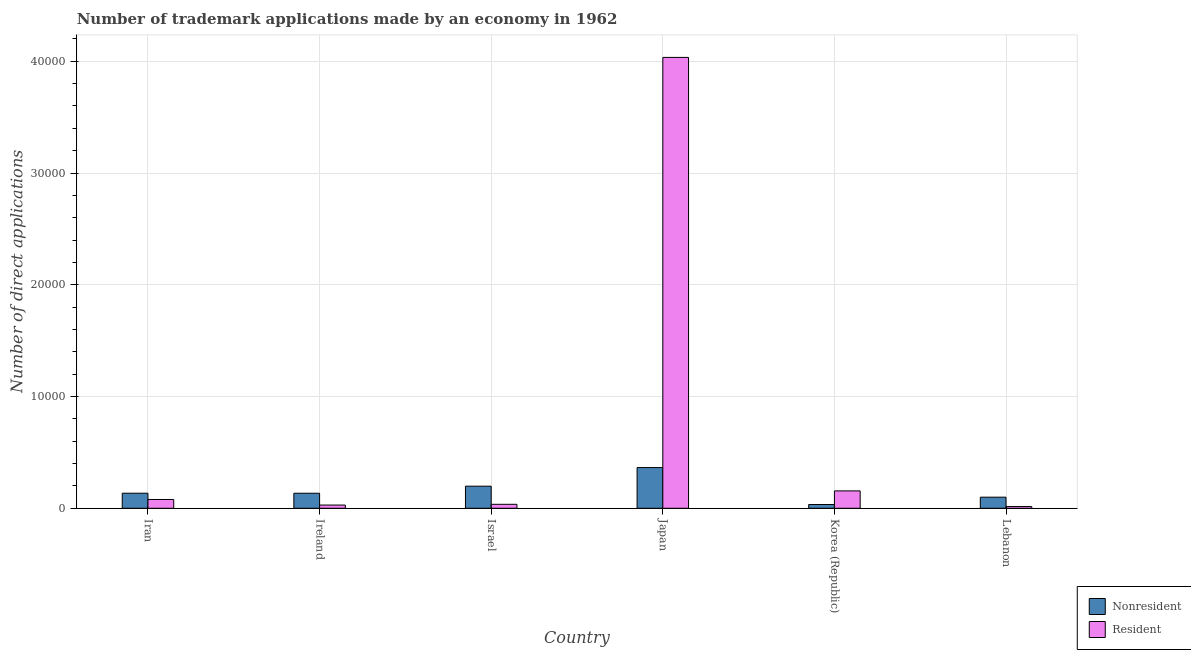How many different coloured bars are there?
Offer a terse response. 2. How many groups of bars are there?
Provide a short and direct response. 6. Are the number of bars per tick equal to the number of legend labels?
Your response must be concise. Yes. How many bars are there on the 3rd tick from the left?
Make the answer very short. 2. How many bars are there on the 5th tick from the right?
Offer a very short reply. 2. What is the label of the 2nd group of bars from the left?
Give a very brief answer. Ireland. What is the number of trademark applications made by residents in Lebanon?
Provide a short and direct response. 153. Across all countries, what is the maximum number of trademark applications made by non residents?
Offer a terse response. 3642. Across all countries, what is the minimum number of trademark applications made by non residents?
Offer a very short reply. 336. In which country was the number of trademark applications made by residents minimum?
Keep it short and to the point. Lebanon. What is the total number of trademark applications made by residents in the graph?
Ensure brevity in your answer.  4.35e+04. What is the difference between the number of trademark applications made by non residents in Korea (Republic) and that in Lebanon?
Offer a terse response. -656. What is the difference between the number of trademark applications made by residents in Iran and the number of trademark applications made by non residents in Japan?
Provide a short and direct response. -2856. What is the average number of trademark applications made by residents per country?
Provide a succinct answer. 7246.5. What is the difference between the number of trademark applications made by residents and number of trademark applications made by non residents in Korea (Republic)?
Your answer should be very brief. 1218. What is the ratio of the number of trademark applications made by non residents in Korea (Republic) to that in Lebanon?
Offer a very short reply. 0.34. Is the number of trademark applications made by residents in Israel less than that in Japan?
Provide a short and direct response. Yes. What is the difference between the highest and the second highest number of trademark applications made by non residents?
Your response must be concise. 1665. What is the difference between the highest and the lowest number of trademark applications made by residents?
Your response must be concise. 4.02e+04. Is the sum of the number of trademark applications made by residents in Ireland and Israel greater than the maximum number of trademark applications made by non residents across all countries?
Keep it short and to the point. No. What does the 2nd bar from the left in Iran represents?
Ensure brevity in your answer.  Resident. What does the 2nd bar from the right in Ireland represents?
Give a very brief answer. Nonresident. How many bars are there?
Offer a very short reply. 12. What is the difference between two consecutive major ticks on the Y-axis?
Provide a short and direct response. 10000. Where does the legend appear in the graph?
Ensure brevity in your answer.  Bottom right. How are the legend labels stacked?
Your response must be concise. Vertical. What is the title of the graph?
Give a very brief answer. Number of trademark applications made by an economy in 1962. Does "Frequency of shipment arrival" appear as one of the legend labels in the graph?
Your answer should be very brief. No. What is the label or title of the X-axis?
Provide a short and direct response. Country. What is the label or title of the Y-axis?
Provide a succinct answer. Number of direct applications. What is the Number of direct applications in Nonresident in Iran?
Give a very brief answer. 1348. What is the Number of direct applications in Resident in Iran?
Give a very brief answer. 786. What is the Number of direct applications in Nonresident in Ireland?
Your answer should be compact. 1345. What is the Number of direct applications in Resident in Ireland?
Make the answer very short. 288. What is the Number of direct applications in Nonresident in Israel?
Your answer should be compact. 1977. What is the Number of direct applications in Resident in Israel?
Ensure brevity in your answer.  355. What is the Number of direct applications of Nonresident in Japan?
Provide a succinct answer. 3642. What is the Number of direct applications of Resident in Japan?
Your answer should be very brief. 4.03e+04. What is the Number of direct applications in Nonresident in Korea (Republic)?
Provide a short and direct response. 336. What is the Number of direct applications in Resident in Korea (Republic)?
Offer a terse response. 1554. What is the Number of direct applications of Nonresident in Lebanon?
Ensure brevity in your answer.  992. What is the Number of direct applications of Resident in Lebanon?
Ensure brevity in your answer.  153. Across all countries, what is the maximum Number of direct applications of Nonresident?
Provide a short and direct response. 3642. Across all countries, what is the maximum Number of direct applications in Resident?
Keep it short and to the point. 4.03e+04. Across all countries, what is the minimum Number of direct applications of Nonresident?
Offer a terse response. 336. Across all countries, what is the minimum Number of direct applications of Resident?
Keep it short and to the point. 153. What is the total Number of direct applications in Nonresident in the graph?
Keep it short and to the point. 9640. What is the total Number of direct applications in Resident in the graph?
Provide a succinct answer. 4.35e+04. What is the difference between the Number of direct applications in Nonresident in Iran and that in Ireland?
Your response must be concise. 3. What is the difference between the Number of direct applications in Resident in Iran and that in Ireland?
Make the answer very short. 498. What is the difference between the Number of direct applications of Nonresident in Iran and that in Israel?
Offer a terse response. -629. What is the difference between the Number of direct applications of Resident in Iran and that in Israel?
Your answer should be very brief. 431. What is the difference between the Number of direct applications of Nonresident in Iran and that in Japan?
Provide a short and direct response. -2294. What is the difference between the Number of direct applications in Resident in Iran and that in Japan?
Offer a very short reply. -3.96e+04. What is the difference between the Number of direct applications in Nonresident in Iran and that in Korea (Republic)?
Give a very brief answer. 1012. What is the difference between the Number of direct applications of Resident in Iran and that in Korea (Republic)?
Keep it short and to the point. -768. What is the difference between the Number of direct applications in Nonresident in Iran and that in Lebanon?
Give a very brief answer. 356. What is the difference between the Number of direct applications in Resident in Iran and that in Lebanon?
Keep it short and to the point. 633. What is the difference between the Number of direct applications in Nonresident in Ireland and that in Israel?
Your response must be concise. -632. What is the difference between the Number of direct applications of Resident in Ireland and that in Israel?
Your answer should be compact. -67. What is the difference between the Number of direct applications of Nonresident in Ireland and that in Japan?
Your answer should be very brief. -2297. What is the difference between the Number of direct applications in Resident in Ireland and that in Japan?
Offer a terse response. -4.01e+04. What is the difference between the Number of direct applications in Nonresident in Ireland and that in Korea (Republic)?
Make the answer very short. 1009. What is the difference between the Number of direct applications in Resident in Ireland and that in Korea (Republic)?
Keep it short and to the point. -1266. What is the difference between the Number of direct applications in Nonresident in Ireland and that in Lebanon?
Ensure brevity in your answer.  353. What is the difference between the Number of direct applications of Resident in Ireland and that in Lebanon?
Keep it short and to the point. 135. What is the difference between the Number of direct applications of Nonresident in Israel and that in Japan?
Your answer should be compact. -1665. What is the difference between the Number of direct applications in Resident in Israel and that in Japan?
Your response must be concise. -4.00e+04. What is the difference between the Number of direct applications of Nonresident in Israel and that in Korea (Republic)?
Offer a very short reply. 1641. What is the difference between the Number of direct applications in Resident in Israel and that in Korea (Republic)?
Your answer should be compact. -1199. What is the difference between the Number of direct applications in Nonresident in Israel and that in Lebanon?
Your response must be concise. 985. What is the difference between the Number of direct applications of Resident in Israel and that in Lebanon?
Offer a very short reply. 202. What is the difference between the Number of direct applications of Nonresident in Japan and that in Korea (Republic)?
Provide a short and direct response. 3306. What is the difference between the Number of direct applications in Resident in Japan and that in Korea (Republic)?
Provide a short and direct response. 3.88e+04. What is the difference between the Number of direct applications of Nonresident in Japan and that in Lebanon?
Offer a terse response. 2650. What is the difference between the Number of direct applications of Resident in Japan and that in Lebanon?
Your response must be concise. 4.02e+04. What is the difference between the Number of direct applications in Nonresident in Korea (Republic) and that in Lebanon?
Provide a succinct answer. -656. What is the difference between the Number of direct applications in Resident in Korea (Republic) and that in Lebanon?
Make the answer very short. 1401. What is the difference between the Number of direct applications of Nonresident in Iran and the Number of direct applications of Resident in Ireland?
Provide a succinct answer. 1060. What is the difference between the Number of direct applications of Nonresident in Iran and the Number of direct applications of Resident in Israel?
Provide a succinct answer. 993. What is the difference between the Number of direct applications of Nonresident in Iran and the Number of direct applications of Resident in Japan?
Your answer should be very brief. -3.90e+04. What is the difference between the Number of direct applications of Nonresident in Iran and the Number of direct applications of Resident in Korea (Republic)?
Keep it short and to the point. -206. What is the difference between the Number of direct applications of Nonresident in Iran and the Number of direct applications of Resident in Lebanon?
Provide a succinct answer. 1195. What is the difference between the Number of direct applications of Nonresident in Ireland and the Number of direct applications of Resident in Israel?
Offer a terse response. 990. What is the difference between the Number of direct applications in Nonresident in Ireland and the Number of direct applications in Resident in Japan?
Provide a succinct answer. -3.90e+04. What is the difference between the Number of direct applications of Nonresident in Ireland and the Number of direct applications of Resident in Korea (Republic)?
Offer a terse response. -209. What is the difference between the Number of direct applications in Nonresident in Ireland and the Number of direct applications in Resident in Lebanon?
Your answer should be very brief. 1192. What is the difference between the Number of direct applications of Nonresident in Israel and the Number of direct applications of Resident in Japan?
Keep it short and to the point. -3.84e+04. What is the difference between the Number of direct applications in Nonresident in Israel and the Number of direct applications in Resident in Korea (Republic)?
Offer a terse response. 423. What is the difference between the Number of direct applications of Nonresident in Israel and the Number of direct applications of Resident in Lebanon?
Offer a very short reply. 1824. What is the difference between the Number of direct applications of Nonresident in Japan and the Number of direct applications of Resident in Korea (Republic)?
Ensure brevity in your answer.  2088. What is the difference between the Number of direct applications in Nonresident in Japan and the Number of direct applications in Resident in Lebanon?
Keep it short and to the point. 3489. What is the difference between the Number of direct applications in Nonresident in Korea (Republic) and the Number of direct applications in Resident in Lebanon?
Offer a terse response. 183. What is the average Number of direct applications in Nonresident per country?
Your response must be concise. 1606.67. What is the average Number of direct applications of Resident per country?
Make the answer very short. 7246.5. What is the difference between the Number of direct applications of Nonresident and Number of direct applications of Resident in Iran?
Make the answer very short. 562. What is the difference between the Number of direct applications in Nonresident and Number of direct applications in Resident in Ireland?
Your response must be concise. 1057. What is the difference between the Number of direct applications of Nonresident and Number of direct applications of Resident in Israel?
Your answer should be very brief. 1622. What is the difference between the Number of direct applications of Nonresident and Number of direct applications of Resident in Japan?
Offer a terse response. -3.67e+04. What is the difference between the Number of direct applications of Nonresident and Number of direct applications of Resident in Korea (Republic)?
Your response must be concise. -1218. What is the difference between the Number of direct applications in Nonresident and Number of direct applications in Resident in Lebanon?
Offer a very short reply. 839. What is the ratio of the Number of direct applications in Resident in Iran to that in Ireland?
Ensure brevity in your answer.  2.73. What is the ratio of the Number of direct applications of Nonresident in Iran to that in Israel?
Your answer should be compact. 0.68. What is the ratio of the Number of direct applications in Resident in Iran to that in Israel?
Offer a very short reply. 2.21. What is the ratio of the Number of direct applications in Nonresident in Iran to that in Japan?
Make the answer very short. 0.37. What is the ratio of the Number of direct applications of Resident in Iran to that in Japan?
Provide a short and direct response. 0.02. What is the ratio of the Number of direct applications in Nonresident in Iran to that in Korea (Republic)?
Make the answer very short. 4.01. What is the ratio of the Number of direct applications in Resident in Iran to that in Korea (Republic)?
Ensure brevity in your answer.  0.51. What is the ratio of the Number of direct applications in Nonresident in Iran to that in Lebanon?
Make the answer very short. 1.36. What is the ratio of the Number of direct applications of Resident in Iran to that in Lebanon?
Your answer should be very brief. 5.14. What is the ratio of the Number of direct applications in Nonresident in Ireland to that in Israel?
Make the answer very short. 0.68. What is the ratio of the Number of direct applications in Resident in Ireland to that in Israel?
Your answer should be very brief. 0.81. What is the ratio of the Number of direct applications of Nonresident in Ireland to that in Japan?
Make the answer very short. 0.37. What is the ratio of the Number of direct applications of Resident in Ireland to that in Japan?
Ensure brevity in your answer.  0.01. What is the ratio of the Number of direct applications of Nonresident in Ireland to that in Korea (Republic)?
Ensure brevity in your answer.  4. What is the ratio of the Number of direct applications in Resident in Ireland to that in Korea (Republic)?
Your answer should be compact. 0.19. What is the ratio of the Number of direct applications of Nonresident in Ireland to that in Lebanon?
Offer a terse response. 1.36. What is the ratio of the Number of direct applications of Resident in Ireland to that in Lebanon?
Keep it short and to the point. 1.88. What is the ratio of the Number of direct applications of Nonresident in Israel to that in Japan?
Make the answer very short. 0.54. What is the ratio of the Number of direct applications in Resident in Israel to that in Japan?
Provide a succinct answer. 0.01. What is the ratio of the Number of direct applications in Nonresident in Israel to that in Korea (Republic)?
Keep it short and to the point. 5.88. What is the ratio of the Number of direct applications in Resident in Israel to that in Korea (Republic)?
Offer a terse response. 0.23. What is the ratio of the Number of direct applications of Nonresident in Israel to that in Lebanon?
Your answer should be compact. 1.99. What is the ratio of the Number of direct applications of Resident in Israel to that in Lebanon?
Provide a short and direct response. 2.32. What is the ratio of the Number of direct applications in Nonresident in Japan to that in Korea (Republic)?
Offer a terse response. 10.84. What is the ratio of the Number of direct applications in Resident in Japan to that in Korea (Republic)?
Keep it short and to the point. 25.96. What is the ratio of the Number of direct applications of Nonresident in Japan to that in Lebanon?
Your answer should be compact. 3.67. What is the ratio of the Number of direct applications in Resident in Japan to that in Lebanon?
Offer a very short reply. 263.68. What is the ratio of the Number of direct applications in Nonresident in Korea (Republic) to that in Lebanon?
Your answer should be compact. 0.34. What is the ratio of the Number of direct applications in Resident in Korea (Republic) to that in Lebanon?
Keep it short and to the point. 10.16. What is the difference between the highest and the second highest Number of direct applications of Nonresident?
Offer a terse response. 1665. What is the difference between the highest and the second highest Number of direct applications in Resident?
Give a very brief answer. 3.88e+04. What is the difference between the highest and the lowest Number of direct applications of Nonresident?
Provide a succinct answer. 3306. What is the difference between the highest and the lowest Number of direct applications of Resident?
Give a very brief answer. 4.02e+04. 